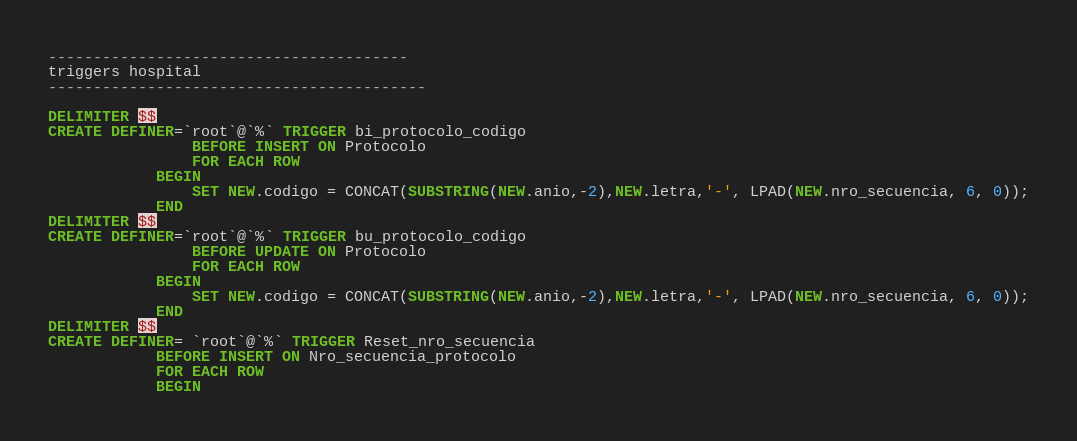<code> <loc_0><loc_0><loc_500><loc_500><_SQL_>----------------------------------------
triggers hospital
------------------------------------------

DELIMITER $$
CREATE DEFINER=`root`@`%` TRIGGER bi_protocolo_codigo
                BEFORE INSERT ON Protocolo
                FOR EACH ROW
            BEGIN
                SET NEW.codigo = CONCAT(SUBSTRING(NEW.anio,-2),NEW.letra,'-', LPAD(NEW.nro_secuencia, 6, 0));
            END
DELIMITER $$
CREATE DEFINER=`root`@`%` TRIGGER bu_protocolo_codigo
                BEFORE UPDATE ON Protocolo
                FOR EACH ROW
            BEGIN
                SET NEW.codigo = CONCAT(SUBSTRING(NEW.anio,-2),NEW.letra,'-', LPAD(NEW.nro_secuencia, 6, 0));
            END
DELIMITER $$
CREATE DEFINER= `root`@`%` TRIGGER Reset_nro_secuencia
            BEFORE INSERT ON Nro_secuencia_protocolo
            FOR EACH ROW
            BEGIN</code> 